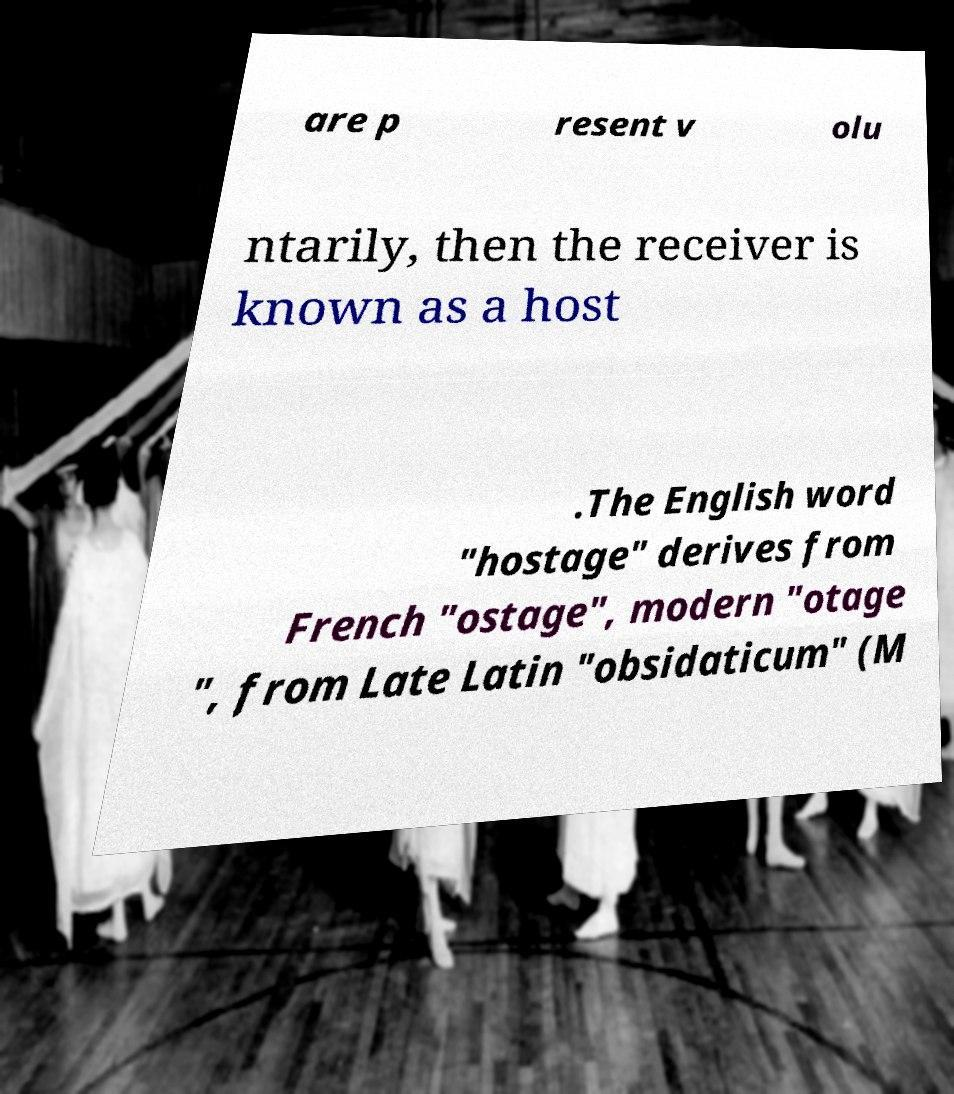For documentation purposes, I need the text within this image transcribed. Could you provide that? are p resent v olu ntarily, then the receiver is known as a host .The English word "hostage" derives from French "ostage", modern "otage ", from Late Latin "obsidaticum" (M 